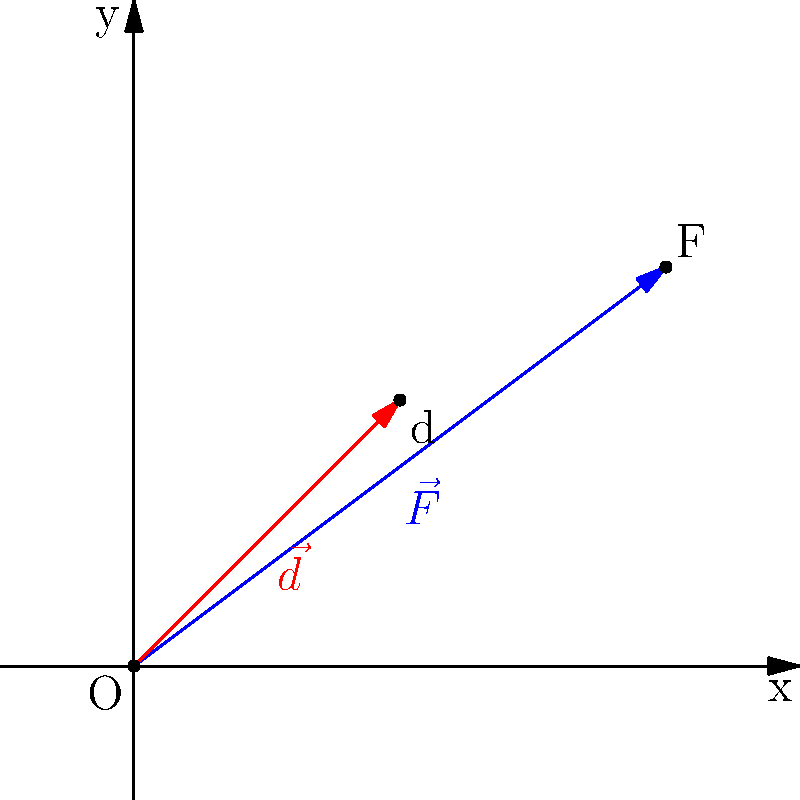In the classic kaiju film "Mecha-Godzilla vs. Tokyo Tower", the heroic robot lifts a section of the famous landmark. If Mecha-Godzilla applies a force $\vec{F} = 4\hat{i} + 3\hat{j}$ (in mega-newtons) to move the tower section a displacement of $\vec{d} = 2\hat{i} + 2\hat{j}$ (in meters), calculate the work done by Mecha-Godzilla. Use the dot product method. To solve this problem, we'll use the dot product method to calculate the work done. The formula for work is:

$$ W = \vec{F} \cdot \vec{d} $$

Where $\vec{F}$ is the force vector and $\vec{d}$ is the displacement vector.

Step 1: Identify the vectors
$\vec{F} = 4\hat{i} + 3\hat{j}$ (mega-newtons)
$\vec{d} = 2\hat{i} + 2\hat{j}$ (meters)

Step 2: Calculate the dot product
$$ \vec{F} \cdot \vec{d} = (4\hat{i} + 3\hat{j}) \cdot (2\hat{i} + 2\hat{j}) $$
$$ = (4 \times 2) + (3 \times 2) $$
$$ = 8 + 6 $$
$$ = 14 $$

Step 3: Interpret the result
The result of the dot product is 14 mega-newton-meters (MN·m).

Therefore, the work done by Mecha-Godzilla in lifting the section of Tokyo Tower is 14 mega-joules (MJ), as 1 newton-meter equals 1 joule.
Answer: 14 MJ 